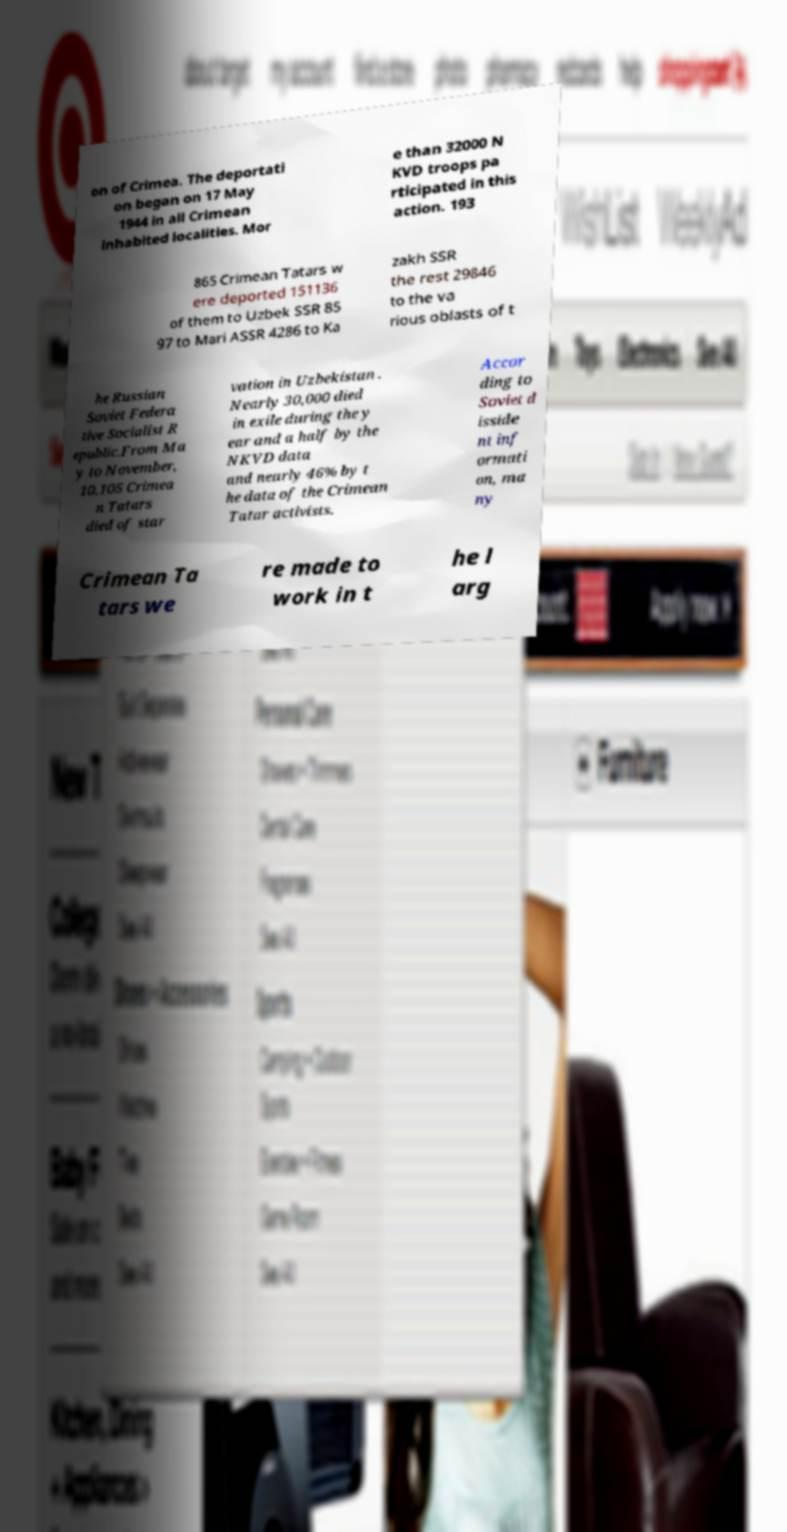For documentation purposes, I need the text within this image transcribed. Could you provide that? on of Crimea. The deportati on began on 17 May 1944 in all Crimean inhabited localities. Mor e than 32000 N KVD troops pa rticipated in this action. 193 865 Crimean Tatars w ere deported 151136 of them to Uzbek SSR 85 97 to Mari ASSR 4286 to Ka zakh SSR the rest 29846 to the va rious oblasts of t he Russian Soviet Federa tive Socialist R epublic.From Ma y to November, 10,105 Crimea n Tatars died of star vation in Uzbekistan . Nearly 30,000 died in exile during the y ear and a half by the NKVD data and nearly 46% by t he data of the Crimean Tatar activists. Accor ding to Soviet d isside nt inf ormati on, ma ny Crimean Ta tars we re made to work in t he l arg 